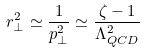Convert formula to latex. <formula><loc_0><loc_0><loc_500><loc_500>r _ { \perp } ^ { 2 } \simeq \frac { 1 } { p _ { \perp } ^ { 2 } } \simeq \frac { \zeta - 1 } { \Lambda _ { Q C D } ^ { 2 } }</formula> 